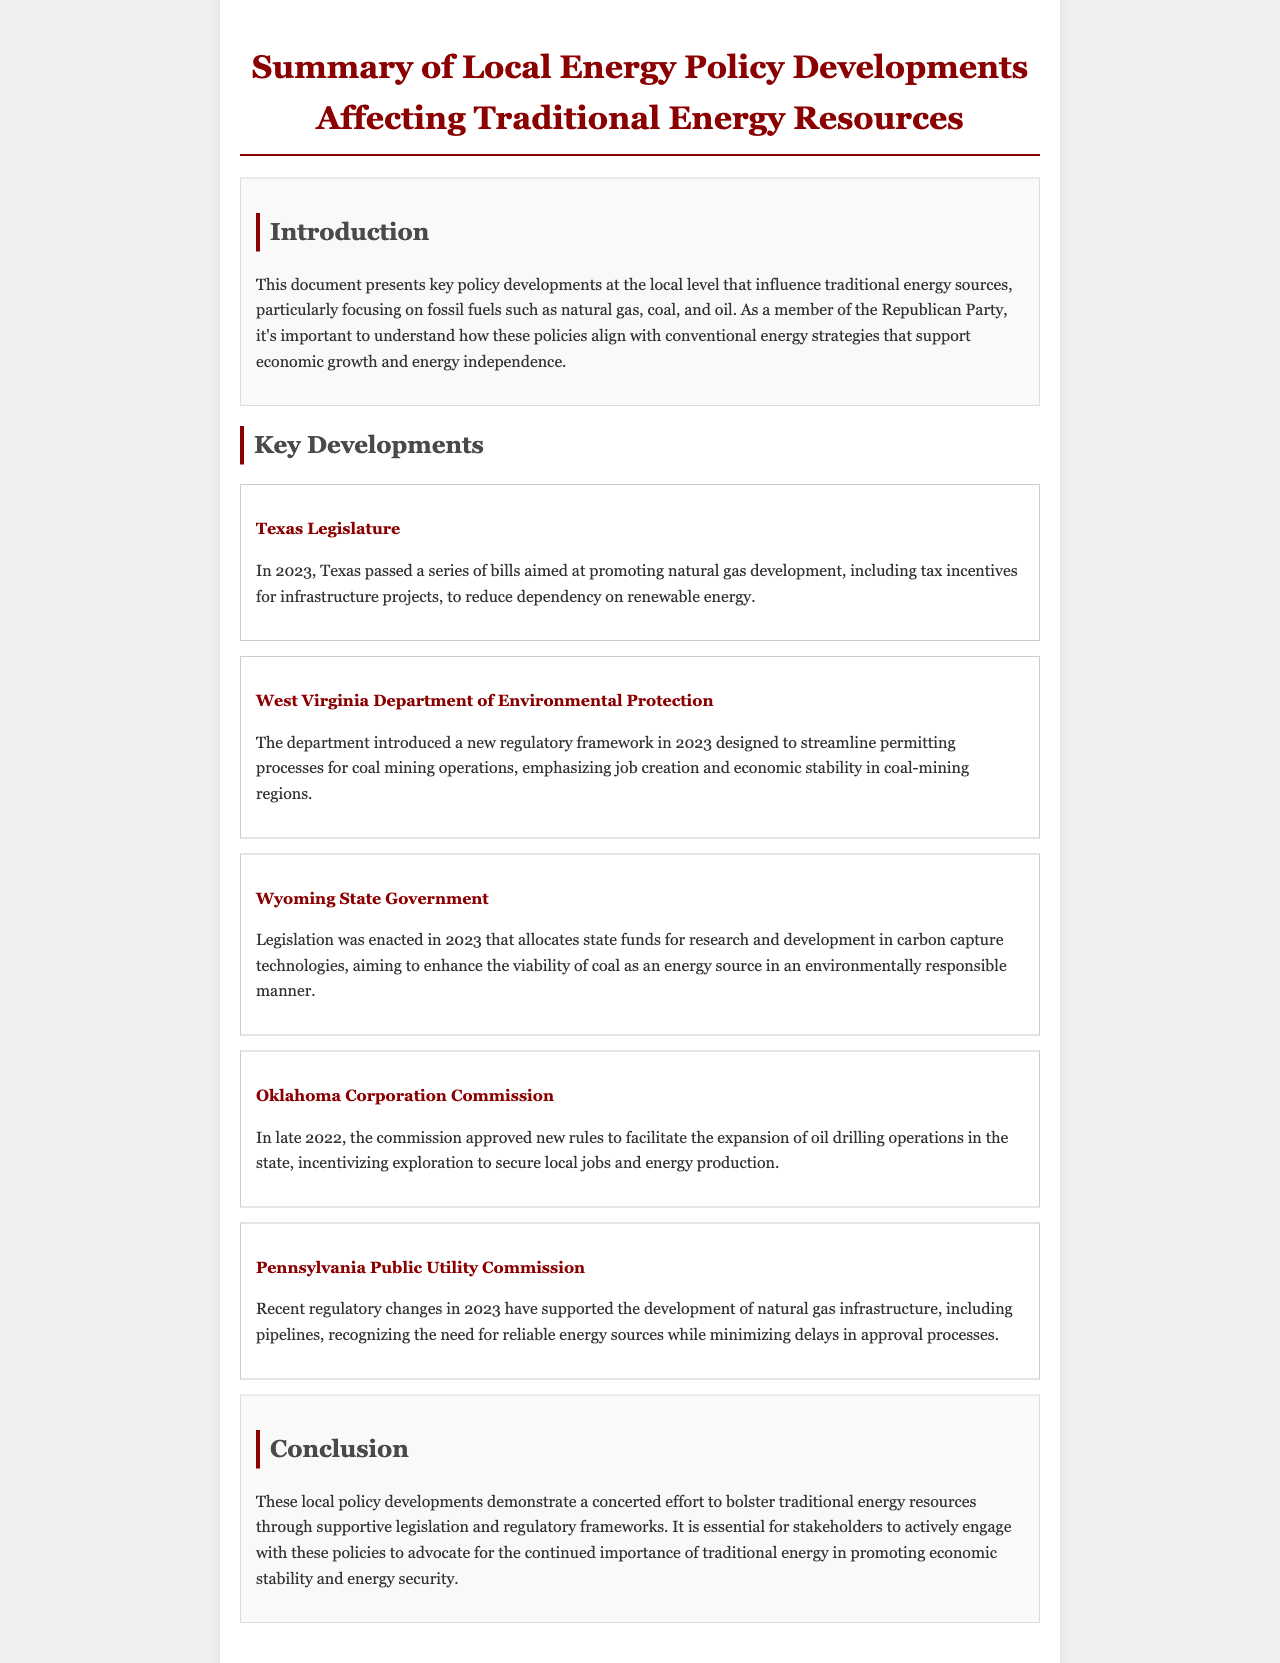What year did Texas pass bills promoting natural gas development? The document states that Texas passed a series of bills in 2023 aimed at promoting natural gas development.
Answer: 2023 Which state introduced a regulatory framework to streamline permitting processes for coal mining? The document mentions that the West Virginia Department of Environmental Protection introduced a new regulatory framework in 2023.
Answer: West Virginia What technology is the Wyoming state government funding research for? According to the document, Wyoming state government allocated funds for research and development in carbon capture technologies.
Answer: Carbon capture technologies What was the focus of the Oklahoma Corporation Commission's approved rules? The document indicates that the newly approved rules by the Oklahoma Corporation Commission focused on facilitating the expansion of oil drilling operations.
Answer: Oil drilling operations What does the Pennsylvania Public Utility Commission support the development of? The document states that recent regulatory changes have supported the development of natural gas infrastructure, including pipelines.
Answer: Natural gas infrastructure What is the main objective of the regulations in West Virginia? The document describes the regulatory framework as emphasizing job creation and economic stability in coal-mining regions.
Answer: Job creation and economic stability What is the overarching theme of the document? The document presents a summary emphasizing a concerted effort to bolster traditional energy resources through supportive legislation and regulatory frameworks.
Answer: Bolstering traditional energy resources 